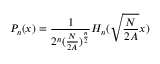<formula> <loc_0><loc_0><loc_500><loc_500>P _ { n } ( x ) = \frac { 1 } { 2 ^ { n } ( \frac { N } { 2 A } ) ^ { \frac { n } { 2 } } } H _ { n } ( \sqrt { \frac { N } { 2 A } } x )</formula> 